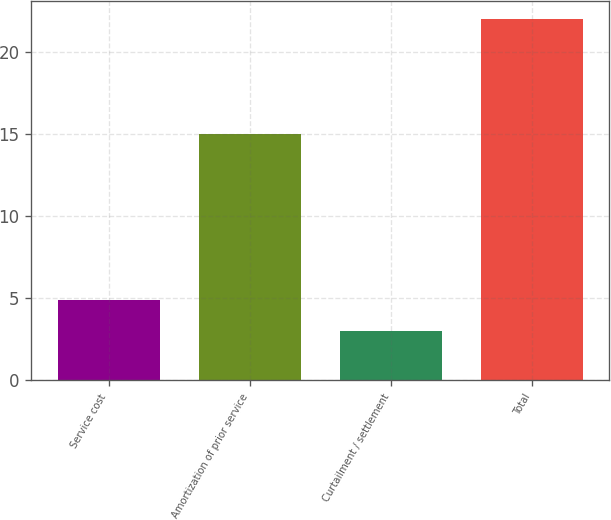Convert chart. <chart><loc_0><loc_0><loc_500><loc_500><bar_chart><fcel>Service cost<fcel>Amortization of prior service<fcel>Curtailment / settlement<fcel>Total<nl><fcel>4.9<fcel>15<fcel>3<fcel>22<nl></chart> 